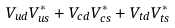Convert formula to latex. <formula><loc_0><loc_0><loc_500><loc_500>V _ { u d } V _ { u s } ^ { * } + V _ { c d } V _ { c s } ^ { * } + V _ { t d } V _ { t s } ^ { * }</formula> 